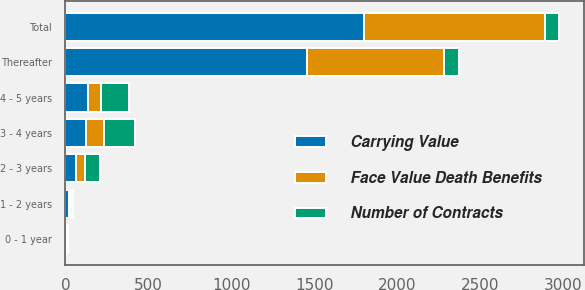Convert chart. <chart><loc_0><loc_0><loc_500><loc_500><stacked_bar_chart><ecel><fcel>0 - 1 year<fcel>1 - 2 years<fcel>2 - 3 years<fcel>3 - 4 years<fcel>4 - 5 years<fcel>Thereafter<fcel>Total<nl><fcel>Carrying Value<fcel>4<fcel>23<fcel>61<fcel>123<fcel>135<fcel>1453<fcel>1799<nl><fcel>Face Value Death Benefits<fcel>6<fcel>10<fcel>58<fcel>108<fcel>79<fcel>829<fcel>1090<nl><fcel>Number of Contracts<fcel>8<fcel>15<fcel>88<fcel>188<fcel>170<fcel>88<fcel>88<nl></chart> 